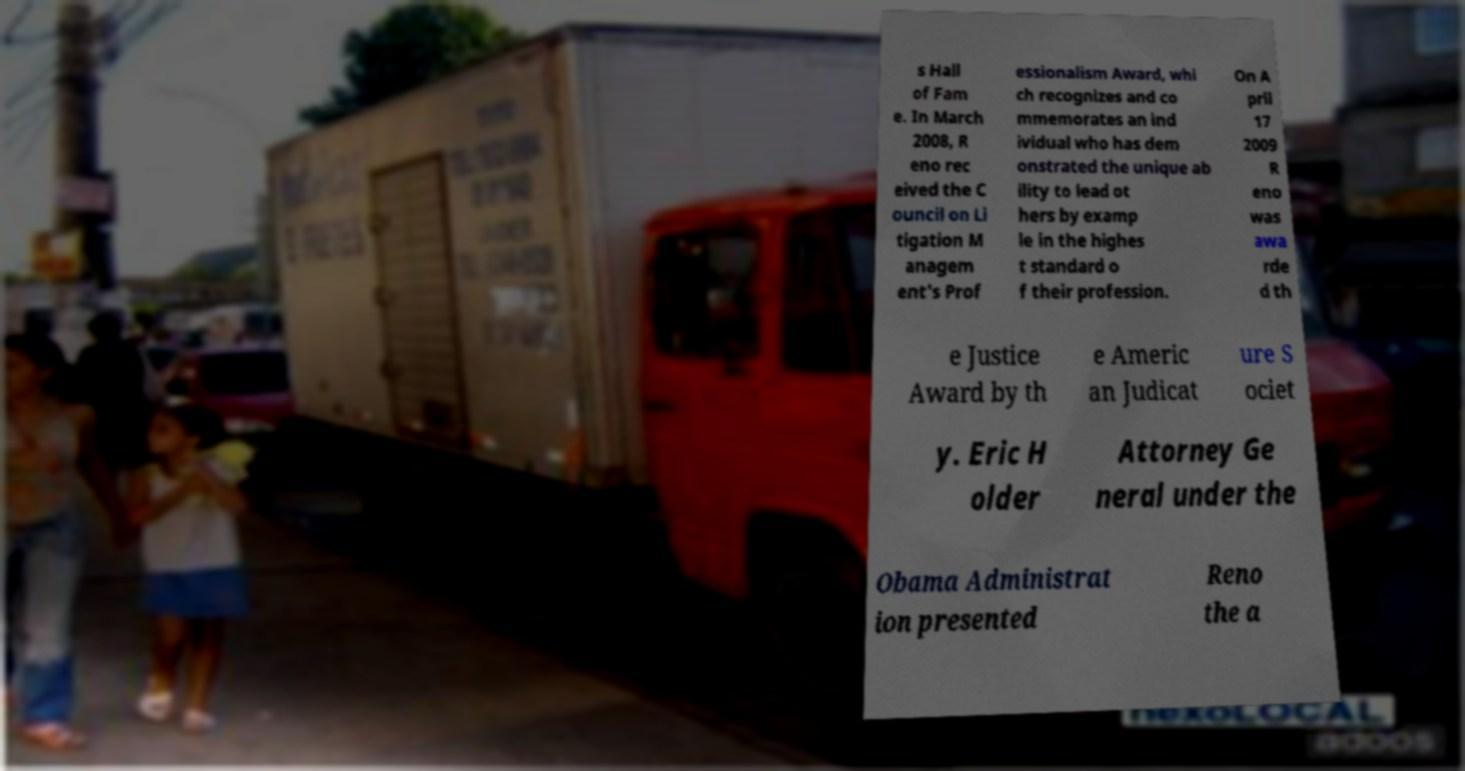Based on the image, can you guess the time of day or the weather conditions? It's challenging to determine the exact time of day due to the lack of visible shadows and lighting conditions in the image. However, the overall brightness and visibility of the sky suggest it might be daytime. As for the weather, it appears to be clear and dry since there are no signs of rain or wet surfaces, and people are wearing light clothing which could indicate a warm or temperate climate. 